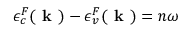<formula> <loc_0><loc_0><loc_500><loc_500>\epsilon _ { c } ^ { F } ( k ) - \epsilon _ { v } ^ { F } ( k ) = n \omega</formula> 